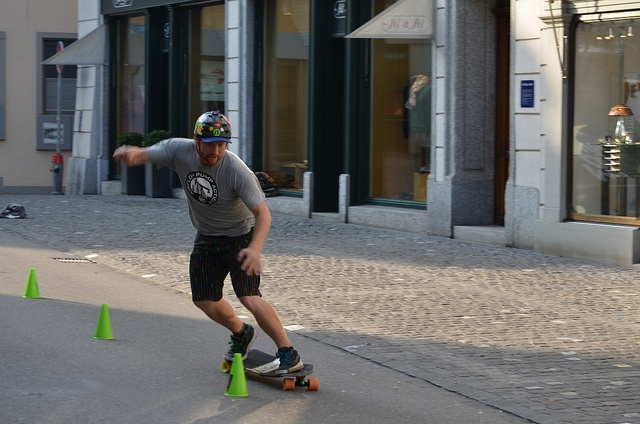Describe the objects in this image and their specific colors. I can see people in gray, black, and maroon tones and skateboard in gray, black, maroon, and darkgray tones in this image. 